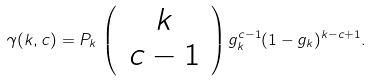<formula> <loc_0><loc_0><loc_500><loc_500>\gamma ( k , c ) = P _ { k } \, \left ( \, \begin{array} { c } k \\ c - 1 \end{array} \, \right ) g _ { k } ^ { c - 1 } ( 1 - g _ { k } ) ^ { k - c + 1 } .</formula> 